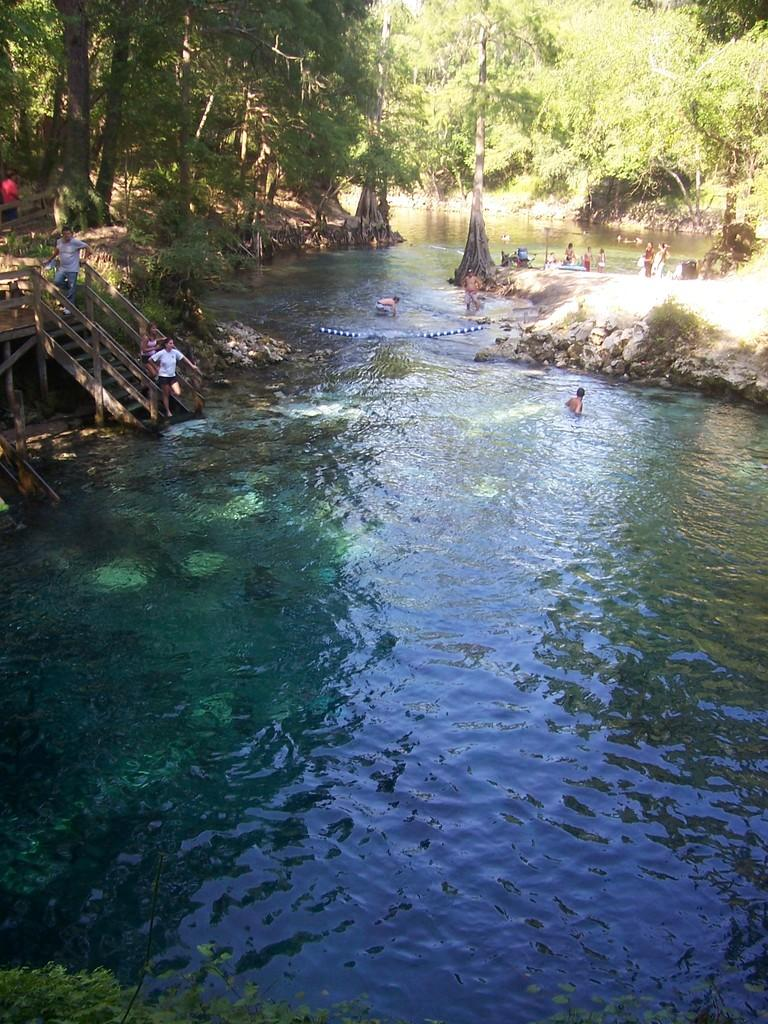What are the two persons in the image doing? The two persons in the image are swimming in the water. What can be seen to the left of the image? There are steps made up of wood to the left of the image. What material are the steps made of? The steps are made of wood. What is visible in the background of the image? There are many trees in the background of the image. What type of surprise can be seen in the water with the swimmers? There is no surprise visible in the water with the swimmers; they are simply swimming. Do the swimmers have fangs in the image? There is no indication of fangs on the swimmers in the image. 